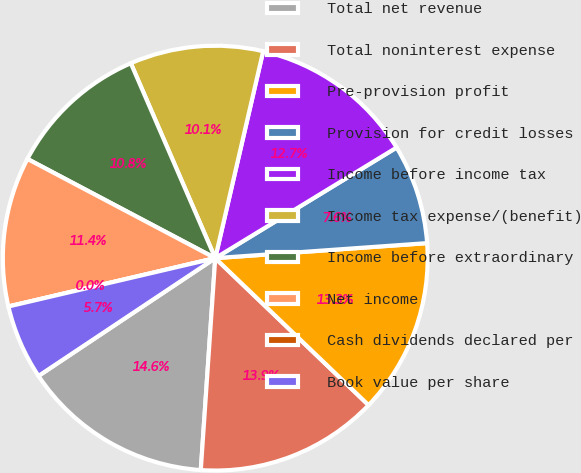<chart> <loc_0><loc_0><loc_500><loc_500><pie_chart><fcel>Total net revenue<fcel>Total noninterest expense<fcel>Pre-provision profit<fcel>Provision for credit losses<fcel>Income before income tax<fcel>Income tax expense/(benefit)<fcel>Income before extraordinary<fcel>Net income<fcel>Cash dividends declared per<fcel>Book value per share<nl><fcel>14.56%<fcel>13.92%<fcel>13.29%<fcel>7.59%<fcel>12.66%<fcel>10.13%<fcel>10.76%<fcel>11.39%<fcel>0.0%<fcel>5.7%<nl></chart> 